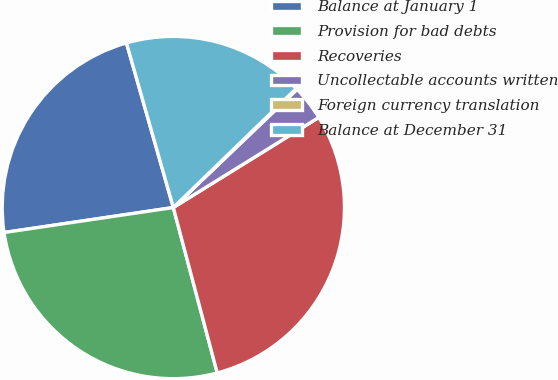Convert chart. <chart><loc_0><loc_0><loc_500><loc_500><pie_chart><fcel>Balance at January 1<fcel>Provision for bad debts<fcel>Recoveries<fcel>Uncollectable accounts written<fcel>Foreign currency translation<fcel>Balance at December 31<nl><fcel>22.92%<fcel>26.8%<fcel>29.7%<fcel>3.31%<fcel>0.11%<fcel>17.17%<nl></chart> 